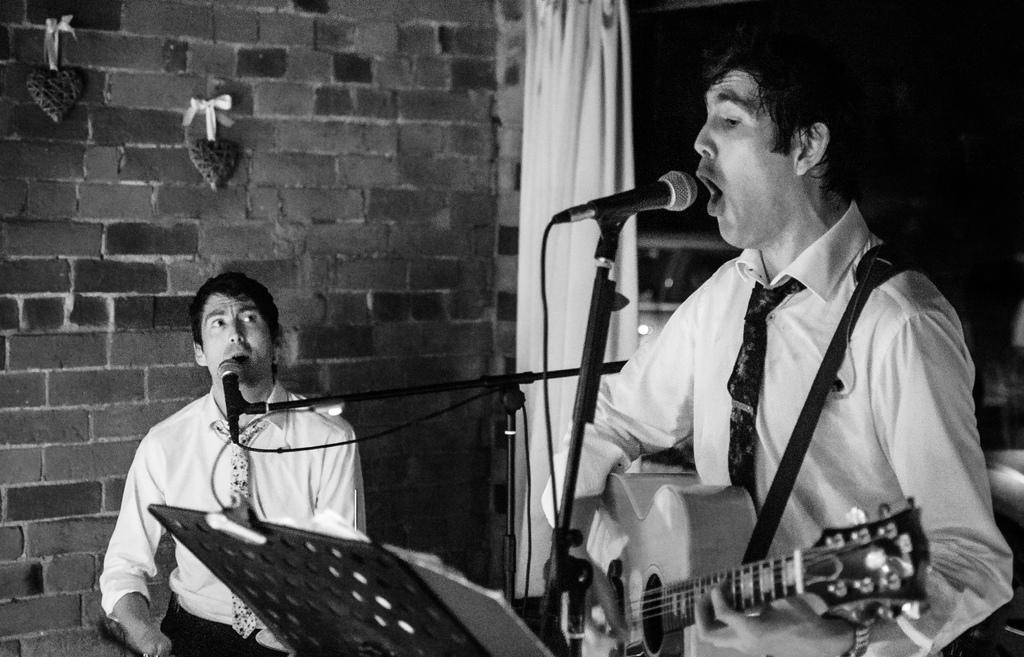How many people are in the image? There are two people in the image. What is one of the people holding? One person is holding a guitar. Can you describe the clothing of the person holding the guitar? The person with the guitar is wearing a white shirt and a tie. What other object is visible in the image? There is a microphone in the image. What type of lettuce is being used as a prop in the image? There is no lettuce present in the image; it features two people, one holding a guitar, and a microphone. 